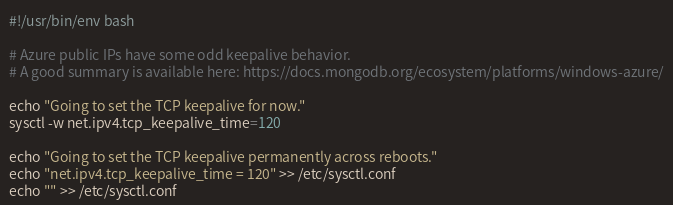Convert code to text. <code><loc_0><loc_0><loc_500><loc_500><_Bash_>#!/usr/bin/env bash

# Azure public IPs have some odd keepalive behavior.
# A good summary is available here: https://docs.mongodb.org/ecosystem/platforms/windows-azure/

echo "Going to set the TCP keepalive for now."
sysctl -w net.ipv4.tcp_keepalive_time=120

echo "Going to set the TCP keepalive permanently across reboots."
echo "net.ipv4.tcp_keepalive_time = 120" >> /etc/sysctl.conf
echo "" >> /etc/sysctl.conf
</code> 